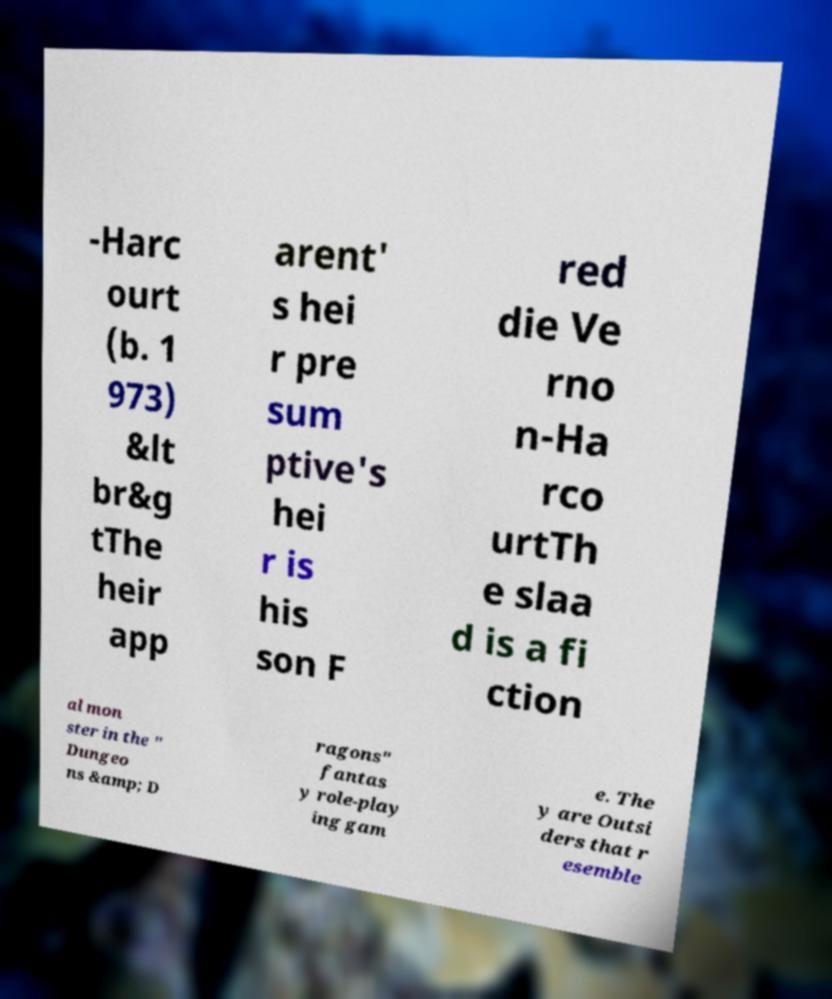Please identify and transcribe the text found in this image. -Harc ourt (b. 1 973) &lt br&g tThe heir app arent' s hei r pre sum ptive's hei r is his son F red die Ve rno n-Ha rco urtTh e slaa d is a fi ction al mon ster in the " Dungeo ns &amp; D ragons" fantas y role-play ing gam e. The y are Outsi ders that r esemble 